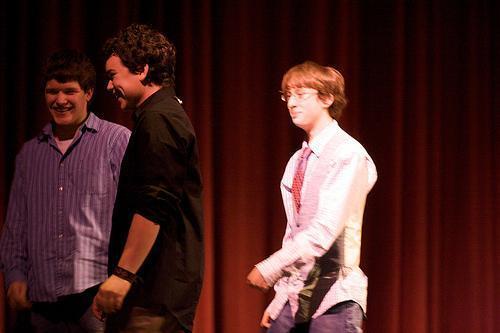How many boys are in the picture?
Give a very brief answer. 3. How many people have purple shirts?
Give a very brief answer. 1. 